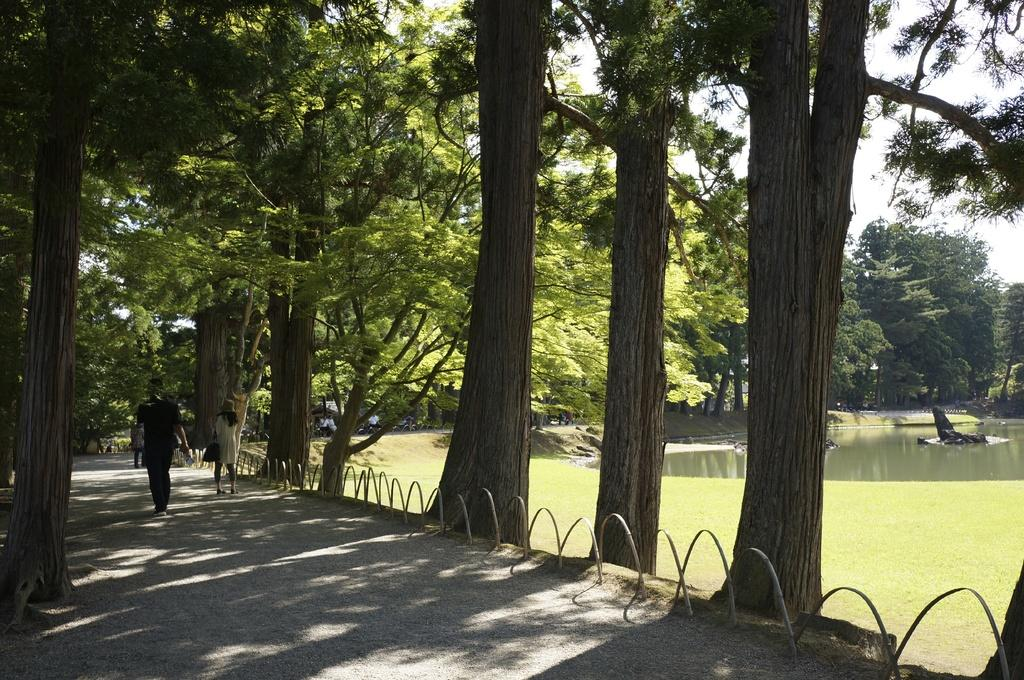What type of vegetation is at the top of the image? There are trees at the top of the image. What are the people at the bottom of the image doing? The people are walking at the bottom of the image. What can be seen behind the people? There is water visible behind the people. Can you see a cat playing in the sand in the image? There is no cat or sand present in the image. How many women are walking at the bottom of the image? The provided facts do not specify the gender of the people walking at the bottom of the image, so we cannot determine the number of women. 